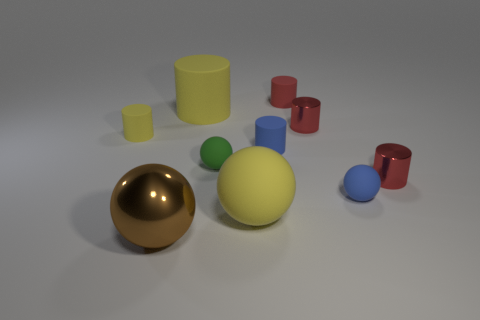What number of things are either tiny balls or tiny matte objects in front of the small yellow matte cylinder?
Ensure brevity in your answer.  3. There is a ball that is to the right of the small red matte cylinder; what is its material?
Make the answer very short. Rubber. There is a red rubber thing that is the same size as the blue sphere; what is its shape?
Your response must be concise. Cylinder. Is there another large yellow thing of the same shape as the big shiny thing?
Your answer should be compact. Yes. Do the green sphere and the blue object that is in front of the blue cylinder have the same material?
Your response must be concise. Yes. There is a tiny ball to the right of the big matte ball that is on the right side of the green rubber sphere; what is it made of?
Give a very brief answer. Rubber. Are there more small things that are on the left side of the brown thing than green cubes?
Offer a terse response. Yes. Is there a large red shiny object?
Provide a short and direct response. No. What color is the big sphere that is to the right of the big brown metallic object?
Keep it short and to the point. Yellow. There is a brown object that is the same size as the yellow ball; what is its material?
Offer a terse response. Metal. 